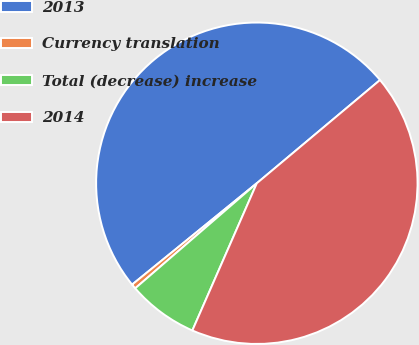Convert chart to OTSL. <chart><loc_0><loc_0><loc_500><loc_500><pie_chart><fcel>2013<fcel>Currency translation<fcel>Total (decrease) increase<fcel>2014<nl><fcel>49.76%<fcel>0.48%<fcel>7.09%<fcel>42.67%<nl></chart> 